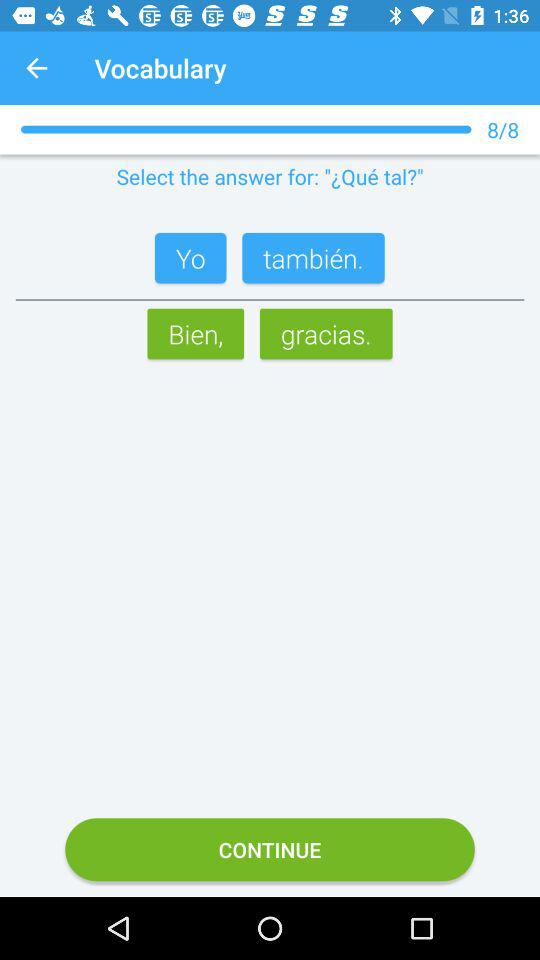How many questions are there? There are 8 questions. 